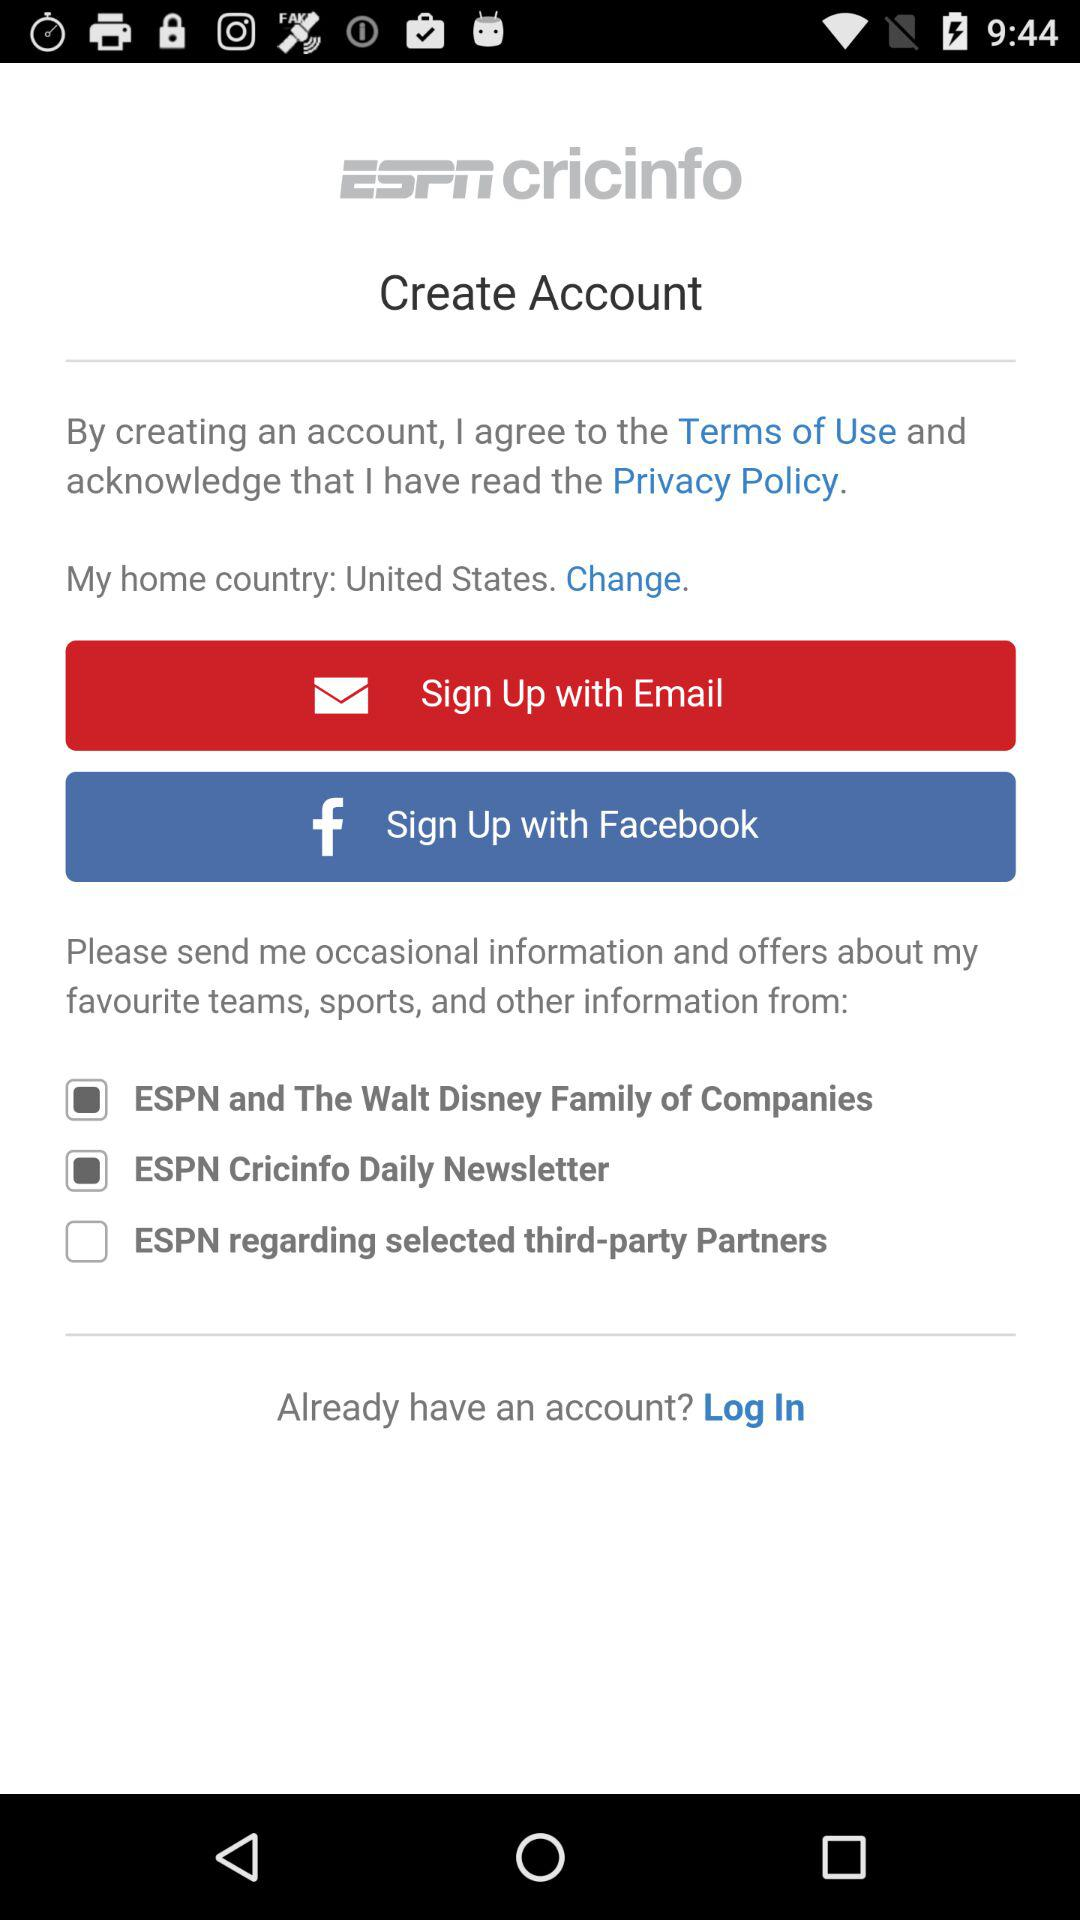What is the status of the "ESPN Cricinfo Daily Newsletter"? The status of the is "on". 